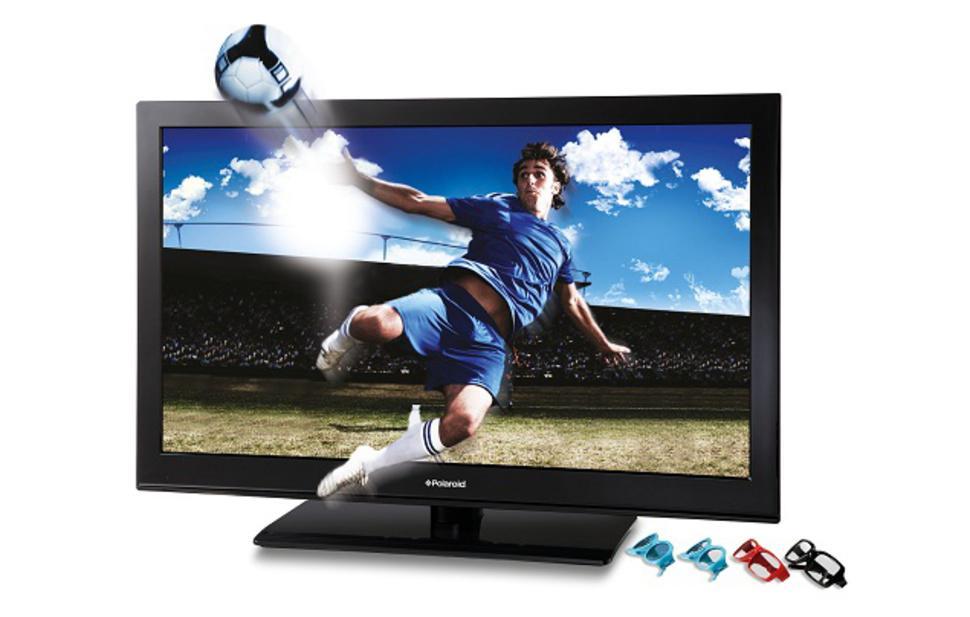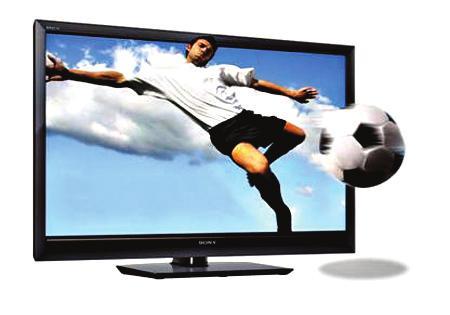The first image is the image on the left, the second image is the image on the right. Examine the images to the left and right. Is the description "There is a vehicle flying in the air on the screen of one of the monitors." accurate? Answer yes or no. No. The first image is the image on the left, the second image is the image on the right. Considering the images on both sides, is "One of the TVs shows a type of aircraft on the screen, with part of the vehicle extending off the screen." valid? Answer yes or no. No. 